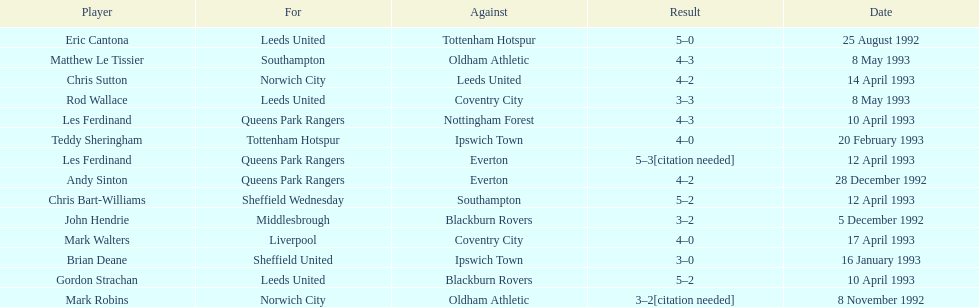In the 1992-1993 premier league, what was the total number of hat tricks scored by all players? 14. 